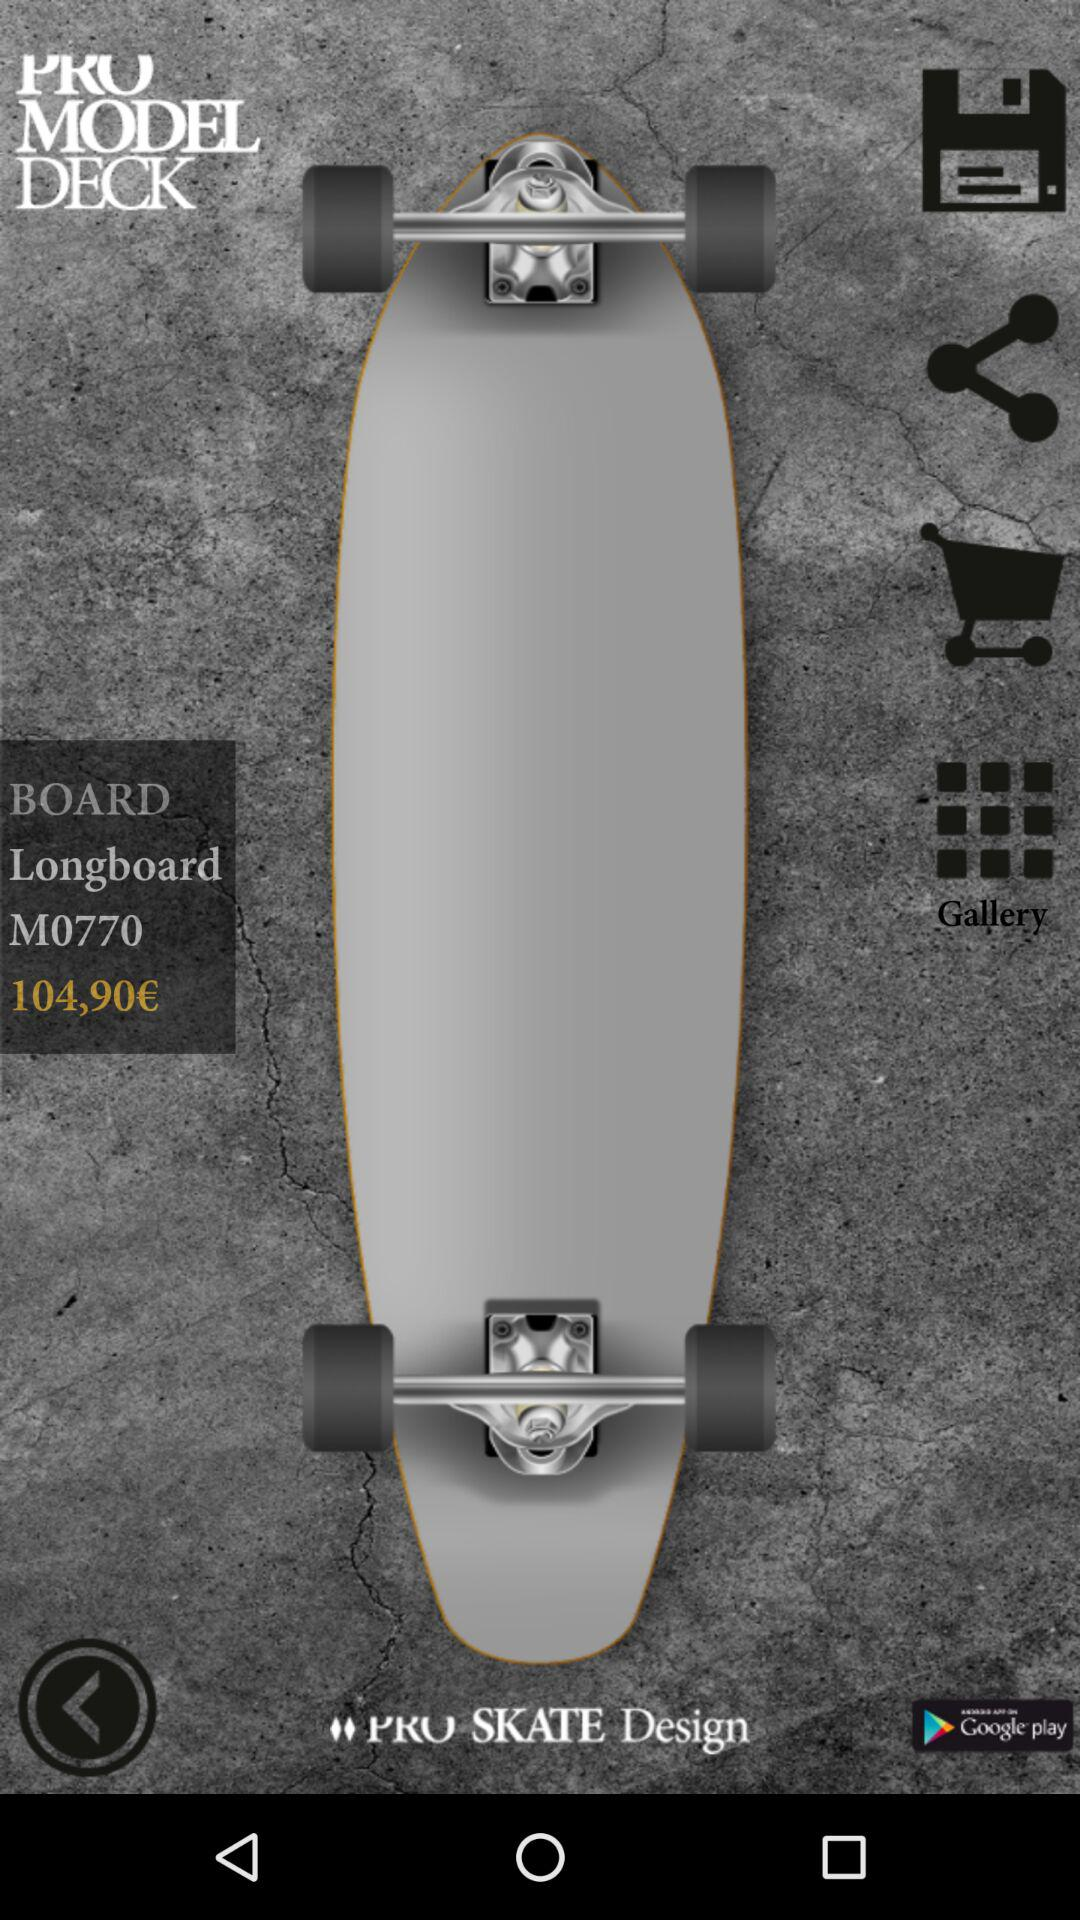What is the price of the "Longboard M0770"? The price is €104,90. 